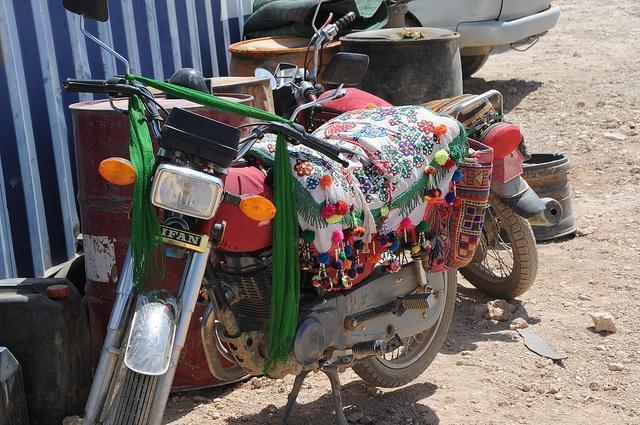How many wheels does this bike have?
Give a very brief answer. 2. How many motorcycles are there?
Give a very brief answer. 2. 